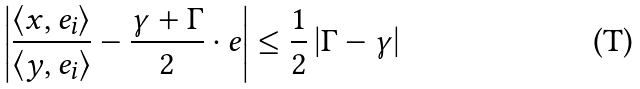Convert formula to latex. <formula><loc_0><loc_0><loc_500><loc_500>\left | \frac { \left \langle x , e _ { i } \right \rangle } { \left \langle y , e _ { i } \right \rangle } - \frac { \gamma + \Gamma } { 2 } \cdot e \right | \leq \frac { 1 } { 2 } \left | \Gamma - \gamma \right |</formula> 